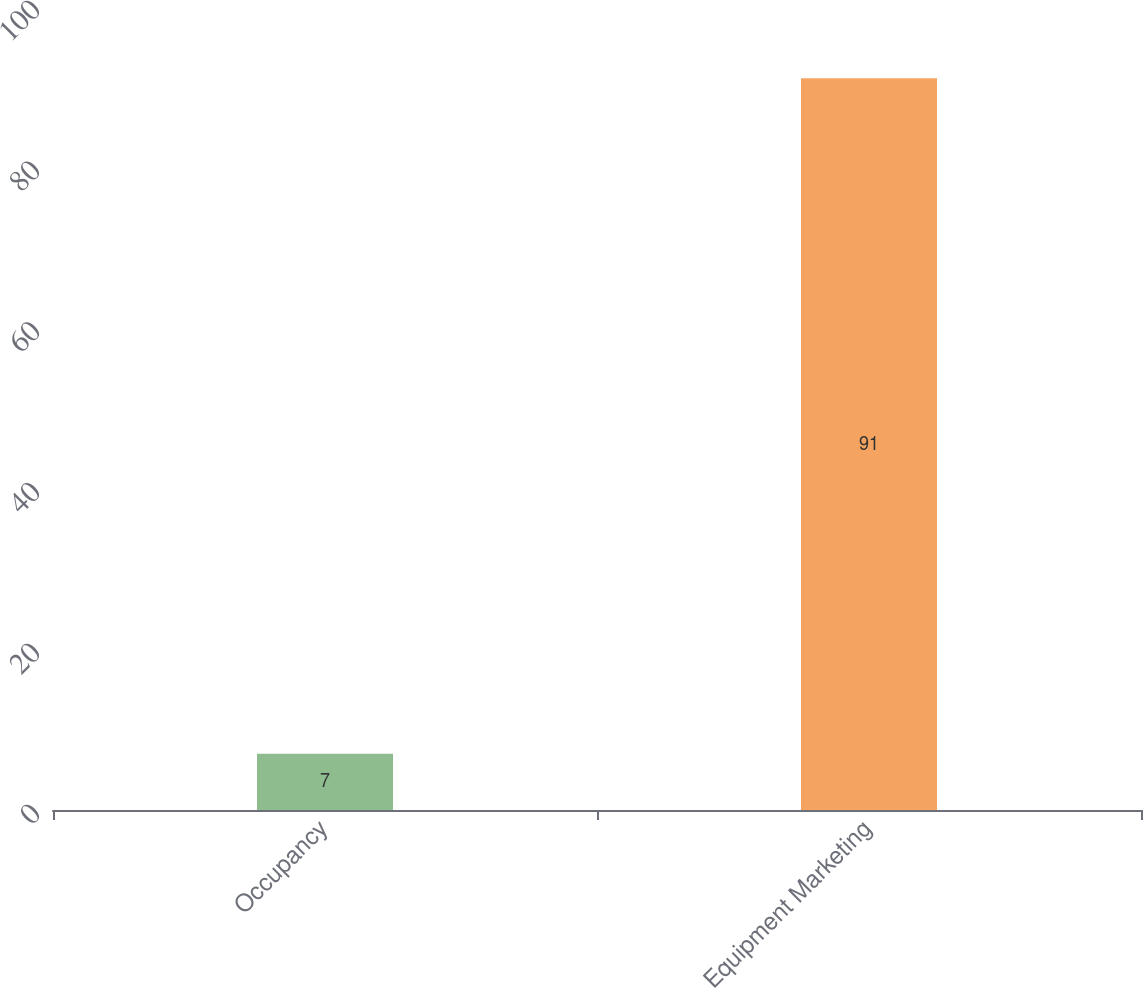Convert chart. <chart><loc_0><loc_0><loc_500><loc_500><bar_chart><fcel>Occupancy<fcel>Equipment Marketing<nl><fcel>7<fcel>91<nl></chart> 